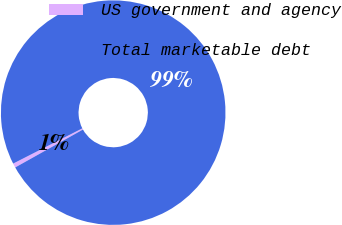Convert chart. <chart><loc_0><loc_0><loc_500><loc_500><pie_chart><fcel>US government and agency<fcel>Total marketable debt<nl><fcel>0.62%<fcel>99.38%<nl></chart> 